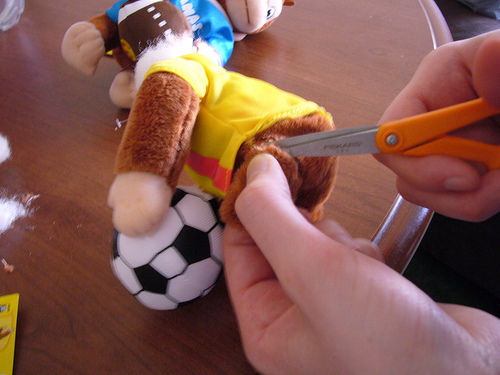<image>
Can you confirm if the table is in front of the toy? No. The table is not in front of the toy. The spatial positioning shows a different relationship between these objects. 